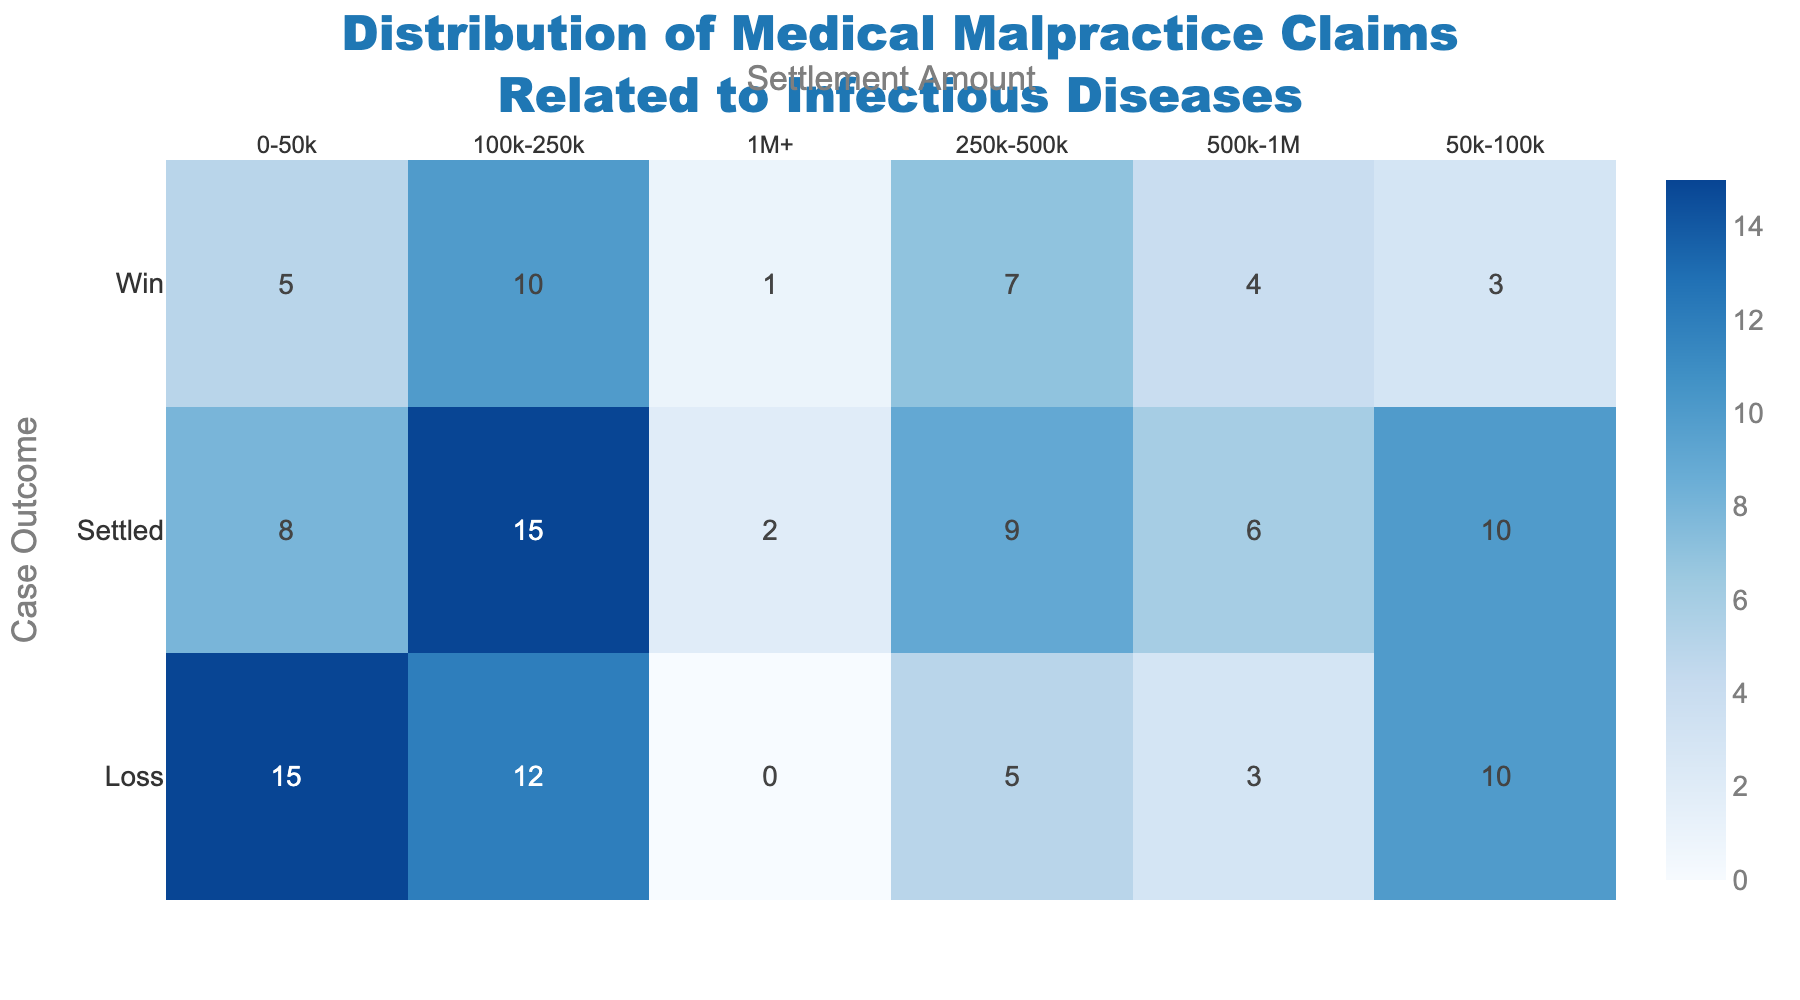what is the total number of claims in the "Win" outcome with a settlement amount of "100k-250k"? In the "Win" outcome row, find the intersection cell with the "100k-250k" column. It shows a claim count of 10.
Answer: 10 Which outcome has the highest number of claims in the settlement amount range "0-50k"? Look down the "0-50k" column to find the highest value. "Loss" has the highest claim count with 15 claims.
Answer: Loss What's the average number of claims for settlements between "50k-100k" across all outcomes? Sum the claim counts in the "50k-100k" column (3+10+10=23) and divide by the number of outcomes (3). The average is 23/3 ≈ 7.67.
Answer: 7.67 How many claims result in settlements greater than "500k" for the "Settled" outcome? Add the claim counts in the "500k-1M" and "1M+" columns for the "Settled" outcome row (6 + 2 = 8).
Answer: 8 Is the number of claims higher for settlements "250k-500k" in "Win" or "Loss" outcomes? Compare the claim counts for "250k-500k" in the "Win" and "Loss" outcome rows. "Win" has 7 claims, while "Loss" has 5 claims, so "Win" is higher.
Answer: Win What's the total number of claims that resulted in settlements over "250k"? Sum all values in the "250k-500k", "500k-1M", and "1M+" columns across all outcomes (7+5+9+4+3+6+1+0+2=37).
Answer: 37 What's the percentage of "Loss" outcomes in the "100k-250k" settlement range out of total claims in the same range? There are 12 claims for "Loss" in the "100k-250k" range. Total claims in that range are 10+12+15=37. The percentage is (12/37)*100 ≈ 32.43%.
Answer: 32.43% Which outcome category has no claims in the "1M+" settlement amount? Check the "1M+" column and find the cell with 0. The "Loss" outcome has 0 claims in the "1M+" settlement amount.
Answer: Loss For the "Settled" outcome, what's the difference in claim count between settlements of "0-50k" and "100k-250k"? Subtract the claim count for "0-50k" from "100k-250k" in the "Settled" outcome row (15 - 8 = 7).
Answer: 7 